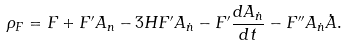<formula> <loc_0><loc_0><loc_500><loc_500>\rho _ { F } = F + F ^ { \prime } A _ { n } - 3 H F ^ { \prime } A _ { \dot { n } } - F ^ { \prime } \frac { d A _ { \dot { n } } } { d t } - F ^ { \prime \prime } A _ { \dot { n } } \dot { A } .</formula> 